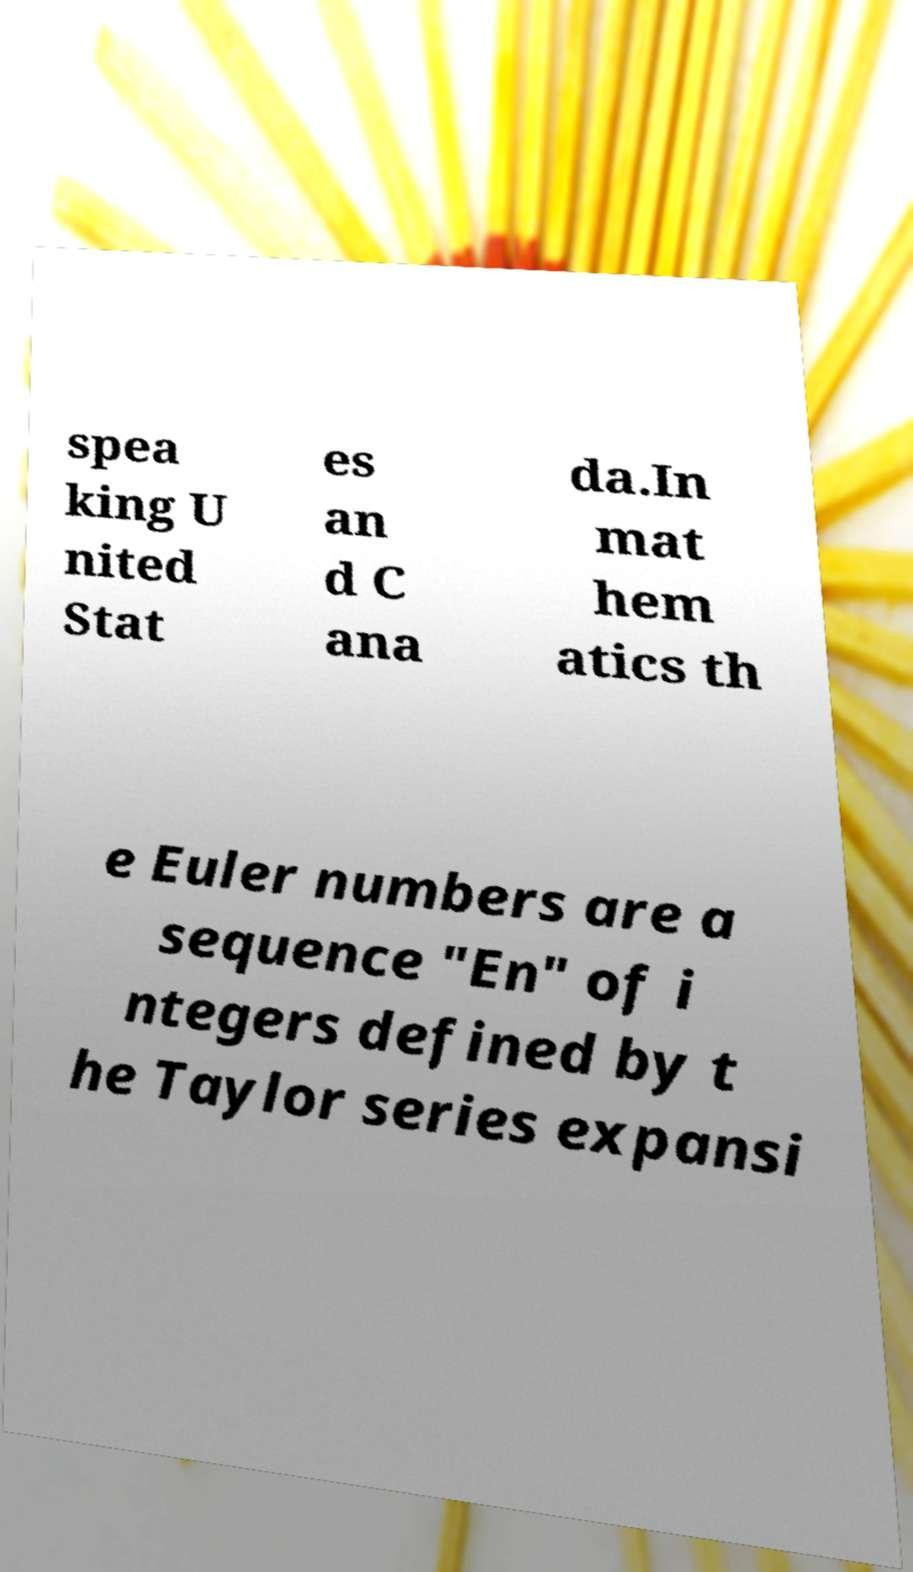There's text embedded in this image that I need extracted. Can you transcribe it verbatim? spea king U nited Stat es an d C ana da.In mat hem atics th e Euler numbers are a sequence "En" of i ntegers defined by t he Taylor series expansi 